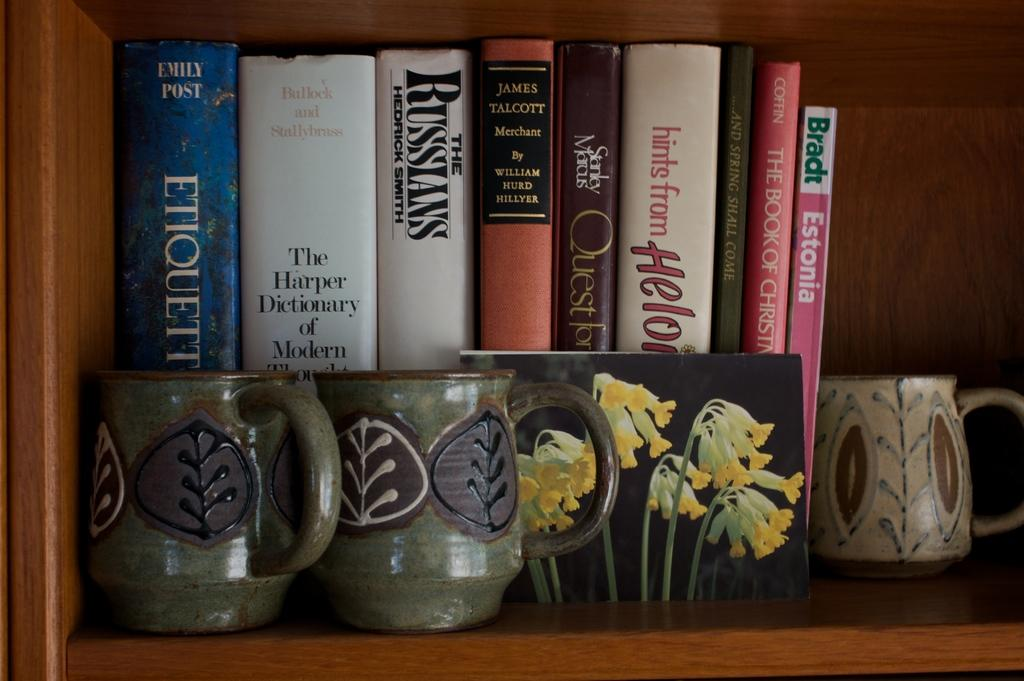<image>
Offer a succinct explanation of the picture presented. A group of books behind a cup and a picture, with one being titled the The Russians. 